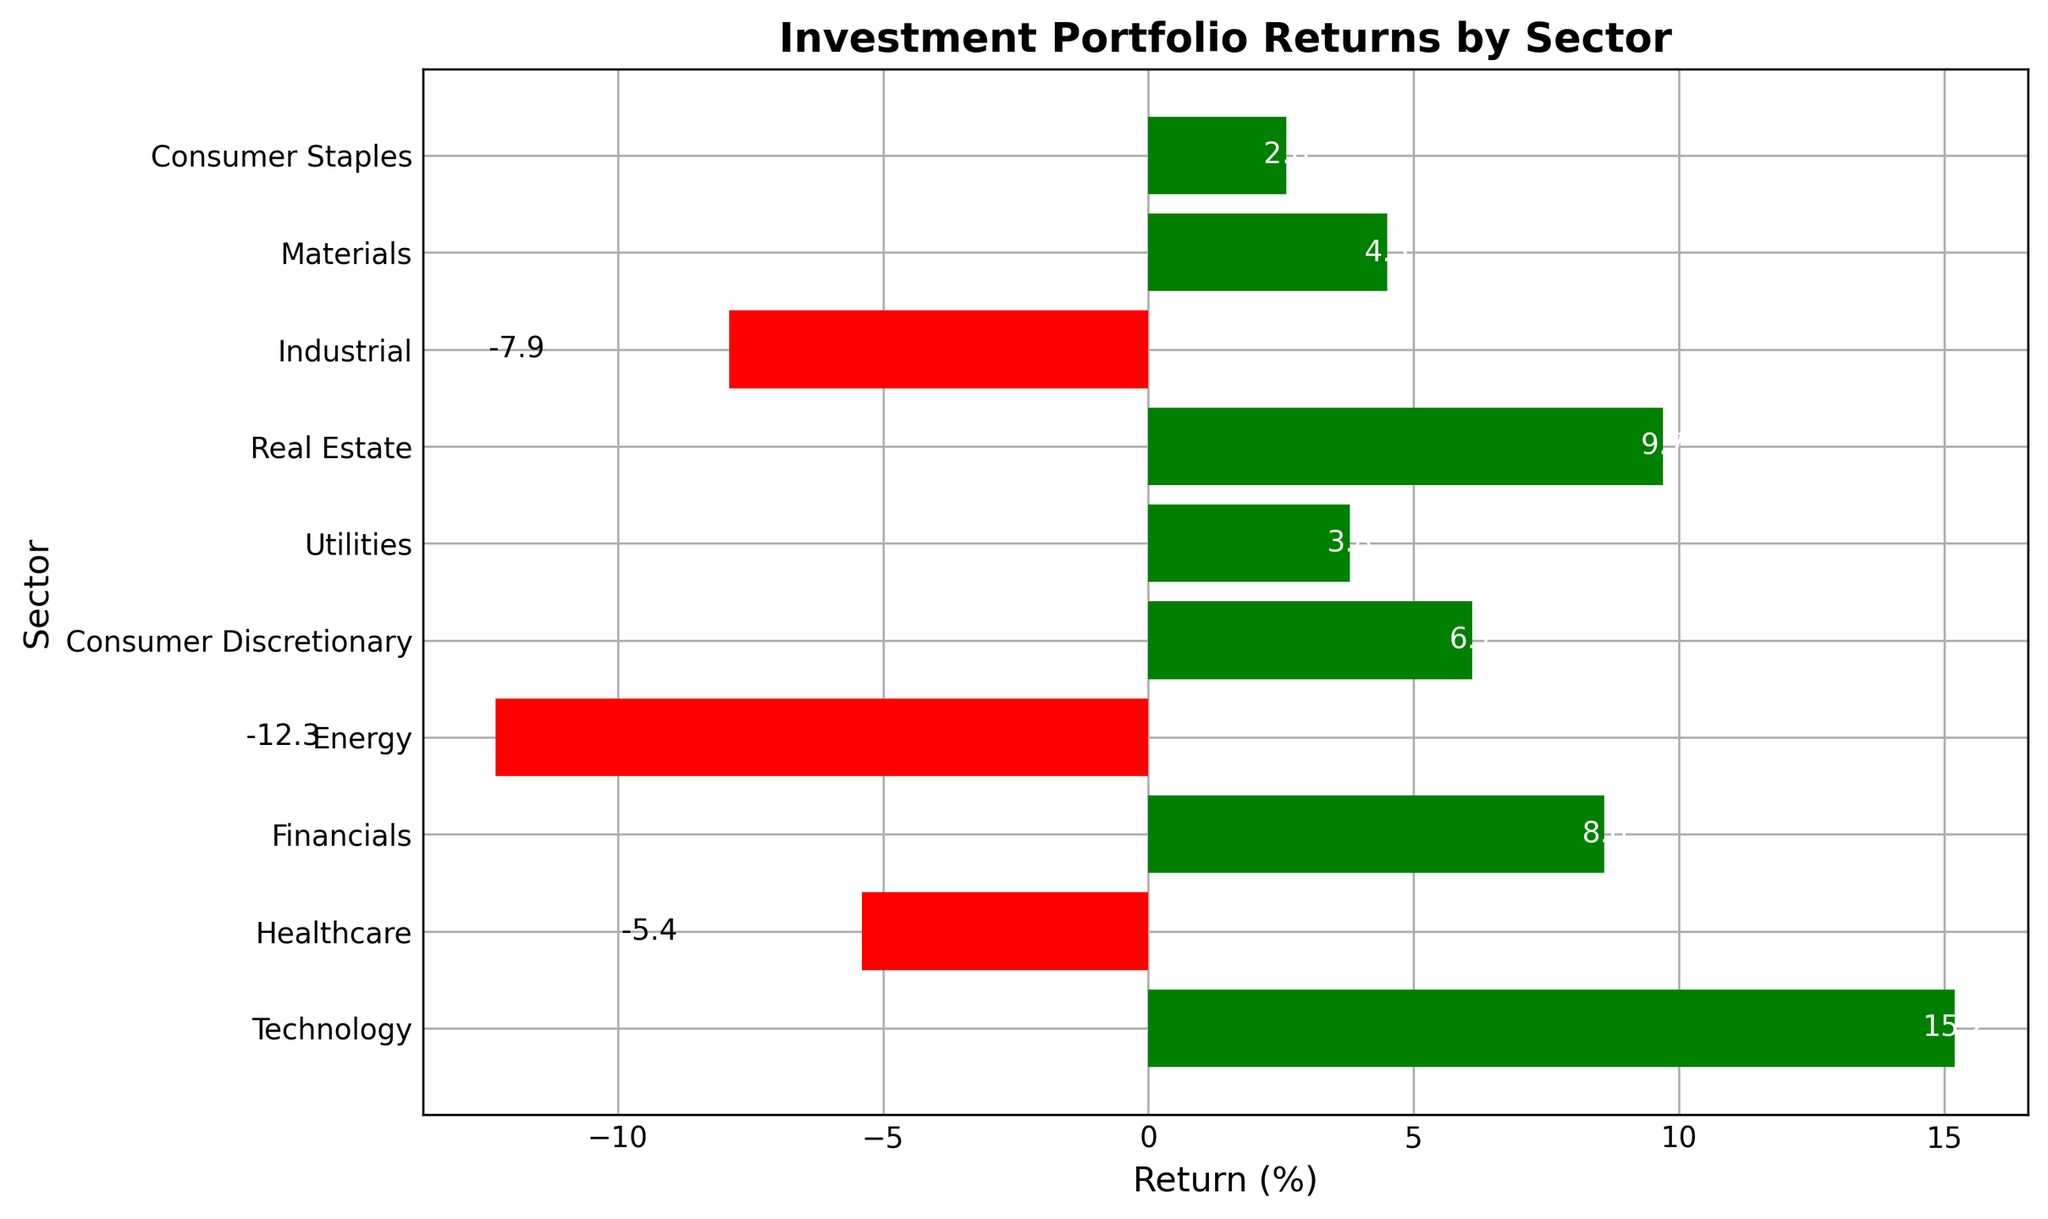What sector has the highest return? The highest return can be identified by comparing the lengths of the green bars. The Technology sector has the longest green bar at 15.2%.
Answer: Technology Which sectors have a negative return? Negative returns are represented by the red bars. The sectors with red bars are Healthcare, Energy, and Industrial.
Answer: Healthcare, Energy, Industrial How much higher is the return of Financials compared to Consumer Staples? The return for Financials is 8.6% and for Consumer Staples is 2.6%. The difference can be calculated as 8.6% - 2.6% = 6%.
Answer: 6% What is the average return across all sectors? To calculate the average, sum all the returns and divide by the number of sectors. Sum is 15.2 + (-5.4) + 8.6 + (-12.3) + 6.1 + 3.8 + 9.7 + (-7.9) + 4.5 + 2.6 = 24.9%. Average is 24.9% / 10 = 2.49%.
Answer: 2.49% Which sector has the lowest return? The lowest return can be identified by comparing the lengths of the red bars. The Energy sector has the longest red bar, indicating a return of -12.3%.
Answer: Energy How many sectors have a return above 5%? Compare the green bars for heights greater than 5%. The applicable sectors are Technology, Financials, Consumer Discretionary, and Real Estate, making a total of 4 sectors.
Answer: 4 What is the combined return of all sectors with a positive return? Add the returns of sectors with green bars: 15.2 + 8.6 + 6.1 + 3.8 + 9.7 + 4.5 + 2.6 = 50.5%.
Answer: 50.5% Which sector has a return closest to zero? Compare the bars to see which sector's return is nearest to the zero line. The Utilities sector, with a return of 3.8%, is the closest.
Answer: Utilities 